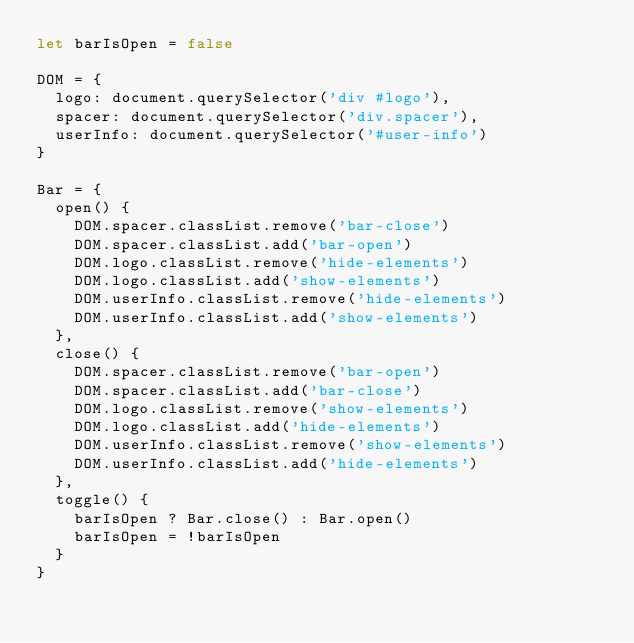Convert code to text. <code><loc_0><loc_0><loc_500><loc_500><_JavaScript_>let barIsOpen = false

DOM = {
  logo: document.querySelector('div #logo'),
  spacer: document.querySelector('div.spacer'),
  userInfo: document.querySelector('#user-info')
}

Bar = {
  open() {
    DOM.spacer.classList.remove('bar-close')
    DOM.spacer.classList.add('bar-open')
    DOM.logo.classList.remove('hide-elements')
    DOM.logo.classList.add('show-elements')
    DOM.userInfo.classList.remove('hide-elements')
    DOM.userInfo.classList.add('show-elements')
  },
  close() {
    DOM.spacer.classList.remove('bar-open')
    DOM.spacer.classList.add('bar-close')
    DOM.logo.classList.remove('show-elements')
    DOM.logo.classList.add('hide-elements')
    DOM.userInfo.classList.remove('show-elements')
    DOM.userInfo.classList.add('hide-elements')
  },
  toggle() {
    barIsOpen ? Bar.close() : Bar.open()
    barIsOpen = !barIsOpen
  }
}
</code> 